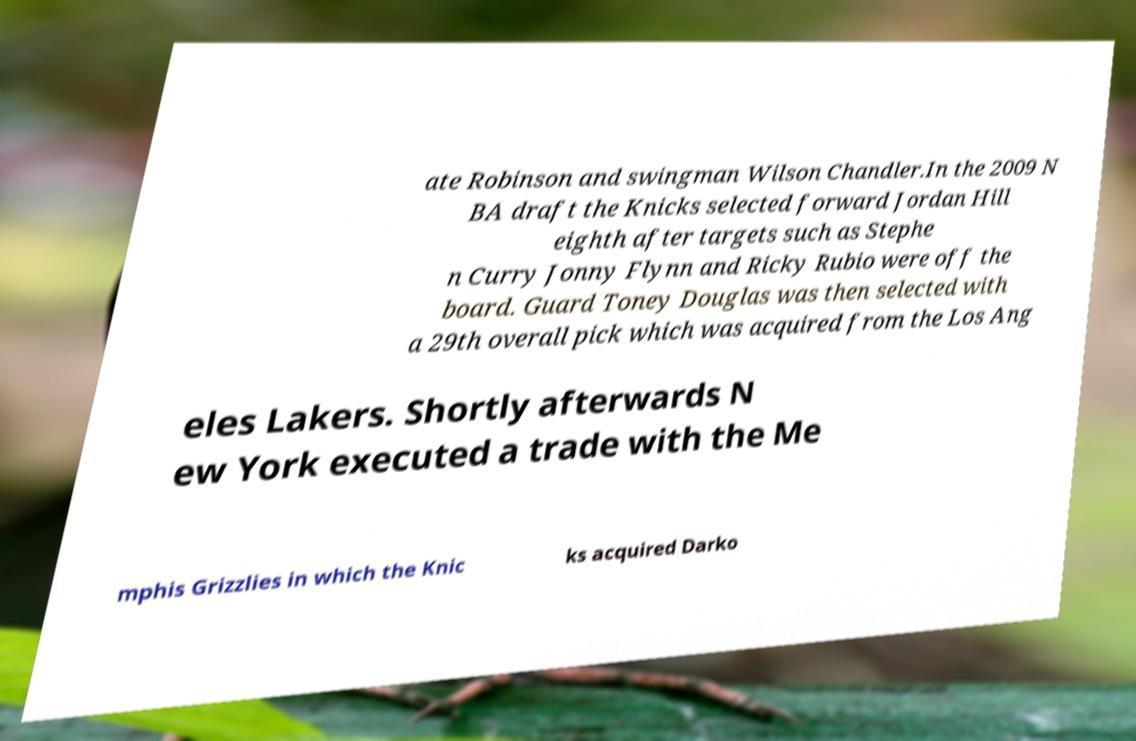Can you accurately transcribe the text from the provided image for me? ate Robinson and swingman Wilson Chandler.In the 2009 N BA draft the Knicks selected forward Jordan Hill eighth after targets such as Stephe n Curry Jonny Flynn and Ricky Rubio were off the board. Guard Toney Douglas was then selected with a 29th overall pick which was acquired from the Los Ang eles Lakers. Shortly afterwards N ew York executed a trade with the Me mphis Grizzlies in which the Knic ks acquired Darko 